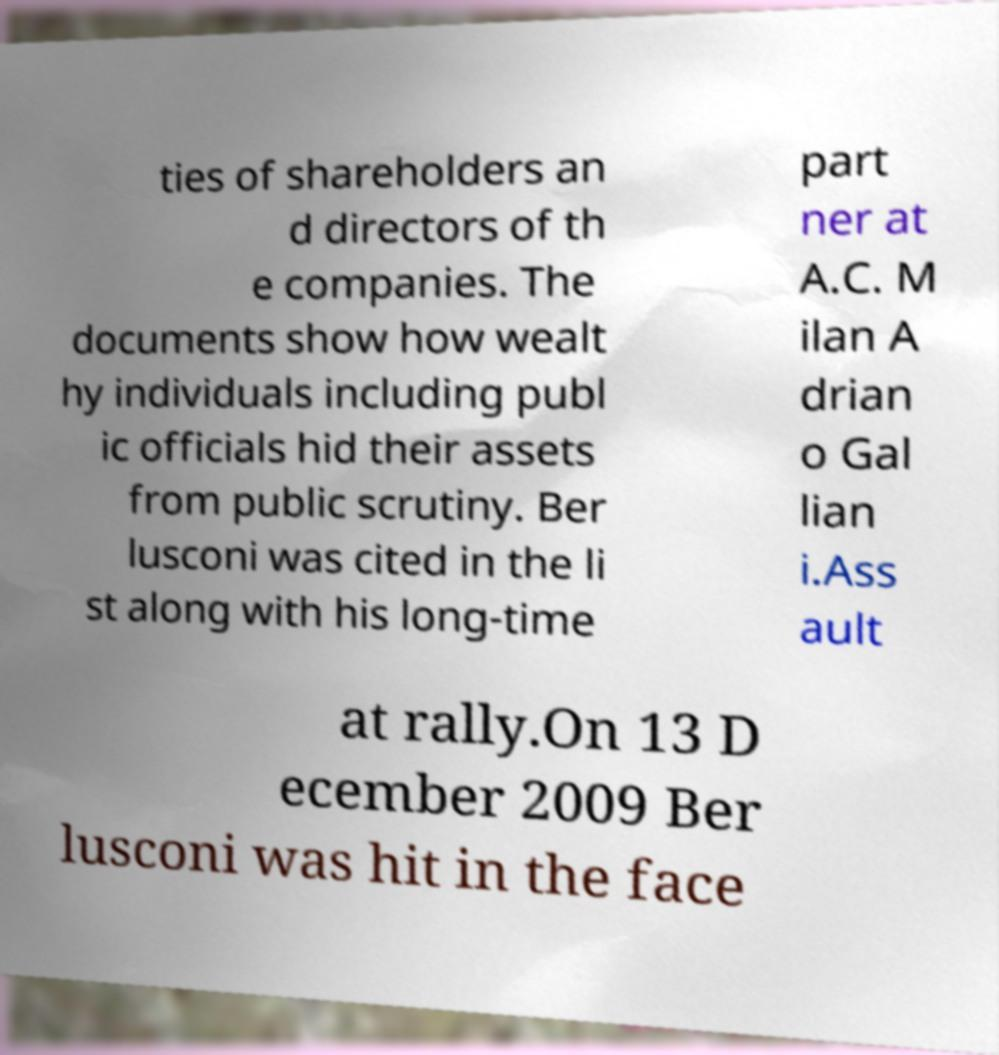I need the written content from this picture converted into text. Can you do that? ties of shareholders an d directors of th e companies. The documents show how wealt hy individuals including publ ic officials hid their assets from public scrutiny. Ber lusconi was cited in the li st along with his long-time part ner at A.C. M ilan A drian o Gal lian i.Ass ault at rally.On 13 D ecember 2009 Ber lusconi was hit in the face 